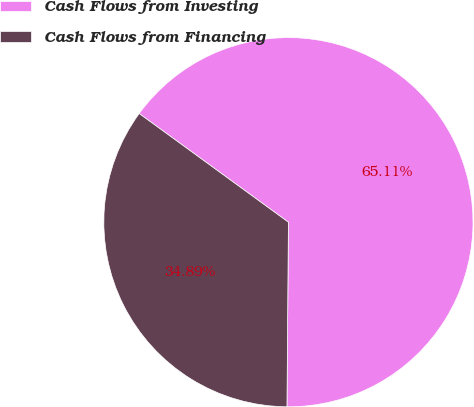<chart> <loc_0><loc_0><loc_500><loc_500><pie_chart><fcel>Cash Flows from Investing<fcel>Cash Flows from Financing<nl><fcel>65.11%<fcel>34.89%<nl></chart> 